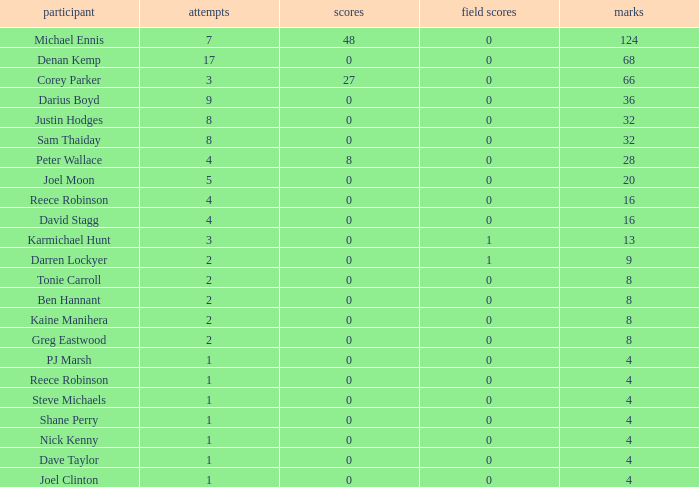What is the total number of field goals of Denan Kemp, who has more than 4 tries, more than 32 points, and 0 goals? 1.0. Parse the table in full. {'header': ['participant', 'attempts', 'scores', 'field scores', 'marks'], 'rows': [['Michael Ennis', '7', '48', '0', '124'], ['Denan Kemp', '17', '0', '0', '68'], ['Corey Parker', '3', '27', '0', '66'], ['Darius Boyd', '9', '0', '0', '36'], ['Justin Hodges', '8', '0', '0', '32'], ['Sam Thaiday', '8', '0', '0', '32'], ['Peter Wallace', '4', '8', '0', '28'], ['Joel Moon', '5', '0', '0', '20'], ['Reece Robinson', '4', '0', '0', '16'], ['David Stagg', '4', '0', '0', '16'], ['Karmichael Hunt', '3', '0', '1', '13'], ['Darren Lockyer', '2', '0', '1', '9'], ['Tonie Carroll', '2', '0', '0', '8'], ['Ben Hannant', '2', '0', '0', '8'], ['Kaine Manihera', '2', '0', '0', '8'], ['Greg Eastwood', '2', '0', '0', '8'], ['PJ Marsh', '1', '0', '0', '4'], ['Reece Robinson', '1', '0', '0', '4'], ['Steve Michaels', '1', '0', '0', '4'], ['Shane Perry', '1', '0', '0', '4'], ['Nick Kenny', '1', '0', '0', '4'], ['Dave Taylor', '1', '0', '0', '4'], ['Joel Clinton', '1', '0', '0', '4']]} 